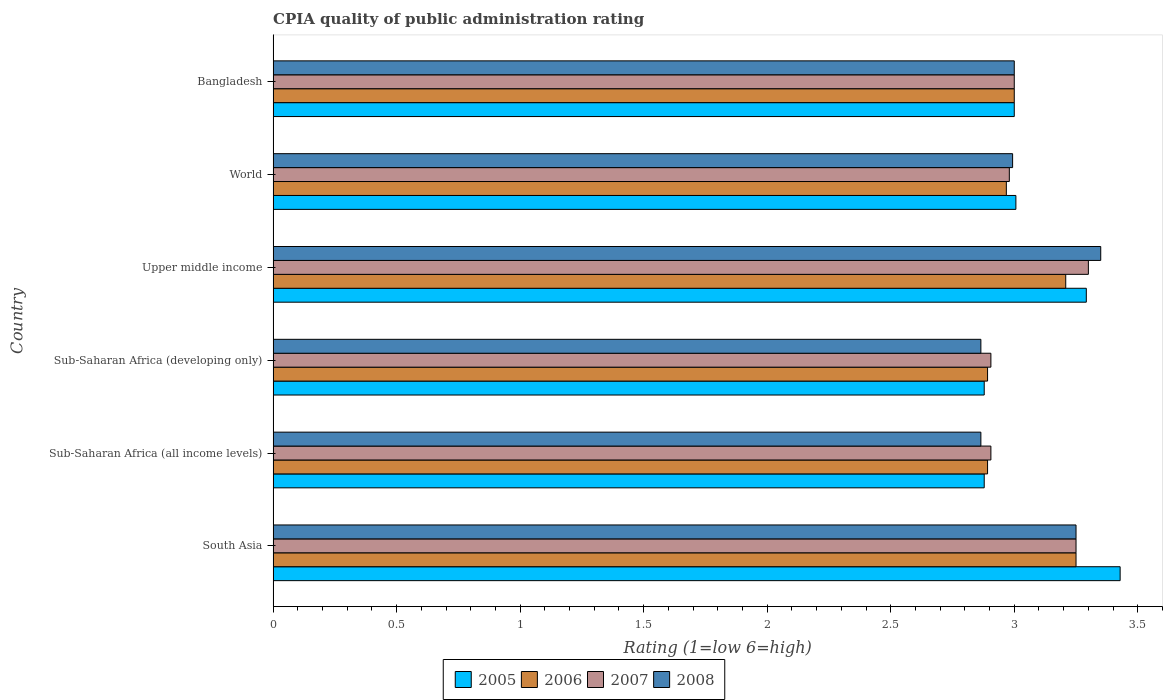How many different coloured bars are there?
Offer a terse response. 4. Are the number of bars per tick equal to the number of legend labels?
Your answer should be compact. Yes. Are the number of bars on each tick of the Y-axis equal?
Provide a succinct answer. Yes. How many bars are there on the 1st tick from the top?
Your answer should be compact. 4. What is the label of the 1st group of bars from the top?
Your answer should be compact. Bangladesh. What is the CPIA rating in 2005 in World?
Offer a terse response. 3.01. Across all countries, what is the minimum CPIA rating in 2006?
Your answer should be compact. 2.89. In which country was the CPIA rating in 2005 maximum?
Provide a short and direct response. South Asia. In which country was the CPIA rating in 2006 minimum?
Your response must be concise. Sub-Saharan Africa (all income levels). What is the total CPIA rating in 2006 in the graph?
Your response must be concise. 18.21. What is the difference between the CPIA rating in 2008 in Sub-Saharan Africa (all income levels) and that in Upper middle income?
Offer a very short reply. -0.49. What is the difference between the CPIA rating in 2006 in Sub-Saharan Africa (developing only) and the CPIA rating in 2008 in World?
Make the answer very short. -0.1. What is the average CPIA rating in 2005 per country?
Your answer should be compact. 3.08. What is the difference between the CPIA rating in 2005 and CPIA rating in 2007 in Upper middle income?
Your response must be concise. -0.01. In how many countries, is the CPIA rating in 2005 greater than 1.2 ?
Provide a succinct answer. 6. What is the ratio of the CPIA rating in 2007 in Sub-Saharan Africa (developing only) to that in Upper middle income?
Give a very brief answer. 0.88. Is the difference between the CPIA rating in 2005 in South Asia and World greater than the difference between the CPIA rating in 2007 in South Asia and World?
Provide a succinct answer. Yes. What is the difference between the highest and the second highest CPIA rating in 2005?
Ensure brevity in your answer.  0.14. What is the difference between the highest and the lowest CPIA rating in 2008?
Your answer should be very brief. 0.49. Is it the case that in every country, the sum of the CPIA rating in 2006 and CPIA rating in 2008 is greater than the sum of CPIA rating in 2005 and CPIA rating in 2007?
Your response must be concise. No. What does the 3rd bar from the top in South Asia represents?
Provide a short and direct response. 2006. Is it the case that in every country, the sum of the CPIA rating in 2008 and CPIA rating in 2005 is greater than the CPIA rating in 2007?
Give a very brief answer. Yes. How many bars are there?
Offer a very short reply. 24. Does the graph contain grids?
Provide a short and direct response. No. How are the legend labels stacked?
Your answer should be compact. Horizontal. What is the title of the graph?
Keep it short and to the point. CPIA quality of public administration rating. Does "1967" appear as one of the legend labels in the graph?
Give a very brief answer. No. What is the label or title of the X-axis?
Make the answer very short. Rating (1=low 6=high). What is the label or title of the Y-axis?
Offer a very short reply. Country. What is the Rating (1=low 6=high) of 2005 in South Asia?
Offer a very short reply. 3.43. What is the Rating (1=low 6=high) in 2006 in South Asia?
Your response must be concise. 3.25. What is the Rating (1=low 6=high) in 2008 in South Asia?
Your response must be concise. 3.25. What is the Rating (1=low 6=high) of 2005 in Sub-Saharan Africa (all income levels)?
Make the answer very short. 2.88. What is the Rating (1=low 6=high) of 2006 in Sub-Saharan Africa (all income levels)?
Ensure brevity in your answer.  2.89. What is the Rating (1=low 6=high) of 2007 in Sub-Saharan Africa (all income levels)?
Your response must be concise. 2.91. What is the Rating (1=low 6=high) in 2008 in Sub-Saharan Africa (all income levels)?
Give a very brief answer. 2.86. What is the Rating (1=low 6=high) of 2005 in Sub-Saharan Africa (developing only)?
Provide a succinct answer. 2.88. What is the Rating (1=low 6=high) in 2006 in Sub-Saharan Africa (developing only)?
Ensure brevity in your answer.  2.89. What is the Rating (1=low 6=high) in 2007 in Sub-Saharan Africa (developing only)?
Keep it short and to the point. 2.91. What is the Rating (1=low 6=high) of 2008 in Sub-Saharan Africa (developing only)?
Provide a succinct answer. 2.86. What is the Rating (1=low 6=high) of 2005 in Upper middle income?
Provide a succinct answer. 3.29. What is the Rating (1=low 6=high) of 2006 in Upper middle income?
Offer a very short reply. 3.21. What is the Rating (1=low 6=high) in 2007 in Upper middle income?
Your answer should be very brief. 3.3. What is the Rating (1=low 6=high) in 2008 in Upper middle income?
Your response must be concise. 3.35. What is the Rating (1=low 6=high) of 2005 in World?
Ensure brevity in your answer.  3.01. What is the Rating (1=low 6=high) of 2006 in World?
Offer a very short reply. 2.97. What is the Rating (1=low 6=high) in 2007 in World?
Provide a short and direct response. 2.98. What is the Rating (1=low 6=high) in 2008 in World?
Keep it short and to the point. 2.99. What is the Rating (1=low 6=high) in 2006 in Bangladesh?
Offer a terse response. 3. Across all countries, what is the maximum Rating (1=low 6=high) in 2005?
Provide a succinct answer. 3.43. Across all countries, what is the maximum Rating (1=low 6=high) of 2006?
Your response must be concise. 3.25. Across all countries, what is the maximum Rating (1=low 6=high) of 2008?
Provide a succinct answer. 3.35. Across all countries, what is the minimum Rating (1=low 6=high) of 2005?
Provide a short and direct response. 2.88. Across all countries, what is the minimum Rating (1=low 6=high) of 2006?
Keep it short and to the point. 2.89. Across all countries, what is the minimum Rating (1=low 6=high) of 2007?
Ensure brevity in your answer.  2.91. Across all countries, what is the minimum Rating (1=low 6=high) of 2008?
Make the answer very short. 2.86. What is the total Rating (1=low 6=high) of 2005 in the graph?
Offer a terse response. 18.48. What is the total Rating (1=low 6=high) in 2006 in the graph?
Your answer should be very brief. 18.21. What is the total Rating (1=low 6=high) in 2007 in the graph?
Provide a succinct answer. 18.34. What is the total Rating (1=low 6=high) of 2008 in the graph?
Make the answer very short. 18.32. What is the difference between the Rating (1=low 6=high) of 2005 in South Asia and that in Sub-Saharan Africa (all income levels)?
Keep it short and to the point. 0.55. What is the difference between the Rating (1=low 6=high) in 2006 in South Asia and that in Sub-Saharan Africa (all income levels)?
Provide a short and direct response. 0.36. What is the difference between the Rating (1=low 6=high) in 2007 in South Asia and that in Sub-Saharan Africa (all income levels)?
Your answer should be compact. 0.34. What is the difference between the Rating (1=low 6=high) of 2008 in South Asia and that in Sub-Saharan Africa (all income levels)?
Offer a terse response. 0.39. What is the difference between the Rating (1=low 6=high) in 2005 in South Asia and that in Sub-Saharan Africa (developing only)?
Your answer should be very brief. 0.55. What is the difference between the Rating (1=low 6=high) in 2006 in South Asia and that in Sub-Saharan Africa (developing only)?
Provide a succinct answer. 0.36. What is the difference between the Rating (1=low 6=high) of 2007 in South Asia and that in Sub-Saharan Africa (developing only)?
Make the answer very short. 0.34. What is the difference between the Rating (1=low 6=high) in 2008 in South Asia and that in Sub-Saharan Africa (developing only)?
Offer a terse response. 0.39. What is the difference between the Rating (1=low 6=high) in 2005 in South Asia and that in Upper middle income?
Give a very brief answer. 0.14. What is the difference between the Rating (1=low 6=high) in 2006 in South Asia and that in Upper middle income?
Make the answer very short. 0.04. What is the difference between the Rating (1=low 6=high) of 2007 in South Asia and that in Upper middle income?
Give a very brief answer. -0.05. What is the difference between the Rating (1=low 6=high) of 2008 in South Asia and that in Upper middle income?
Keep it short and to the point. -0.1. What is the difference between the Rating (1=low 6=high) in 2005 in South Asia and that in World?
Keep it short and to the point. 0.42. What is the difference between the Rating (1=low 6=high) of 2006 in South Asia and that in World?
Offer a very short reply. 0.28. What is the difference between the Rating (1=low 6=high) of 2007 in South Asia and that in World?
Provide a succinct answer. 0.27. What is the difference between the Rating (1=low 6=high) of 2008 in South Asia and that in World?
Provide a succinct answer. 0.26. What is the difference between the Rating (1=low 6=high) in 2005 in South Asia and that in Bangladesh?
Keep it short and to the point. 0.43. What is the difference between the Rating (1=low 6=high) in 2007 in South Asia and that in Bangladesh?
Keep it short and to the point. 0.25. What is the difference between the Rating (1=low 6=high) of 2005 in Sub-Saharan Africa (all income levels) and that in Sub-Saharan Africa (developing only)?
Provide a succinct answer. 0. What is the difference between the Rating (1=low 6=high) of 2007 in Sub-Saharan Africa (all income levels) and that in Sub-Saharan Africa (developing only)?
Make the answer very short. 0. What is the difference between the Rating (1=low 6=high) in 2008 in Sub-Saharan Africa (all income levels) and that in Sub-Saharan Africa (developing only)?
Give a very brief answer. 0. What is the difference between the Rating (1=low 6=high) in 2005 in Sub-Saharan Africa (all income levels) and that in Upper middle income?
Keep it short and to the point. -0.41. What is the difference between the Rating (1=low 6=high) in 2006 in Sub-Saharan Africa (all income levels) and that in Upper middle income?
Offer a very short reply. -0.32. What is the difference between the Rating (1=low 6=high) of 2007 in Sub-Saharan Africa (all income levels) and that in Upper middle income?
Your answer should be very brief. -0.39. What is the difference between the Rating (1=low 6=high) of 2008 in Sub-Saharan Africa (all income levels) and that in Upper middle income?
Make the answer very short. -0.49. What is the difference between the Rating (1=low 6=high) of 2005 in Sub-Saharan Africa (all income levels) and that in World?
Offer a terse response. -0.13. What is the difference between the Rating (1=low 6=high) in 2006 in Sub-Saharan Africa (all income levels) and that in World?
Your answer should be compact. -0.08. What is the difference between the Rating (1=low 6=high) of 2007 in Sub-Saharan Africa (all income levels) and that in World?
Offer a terse response. -0.07. What is the difference between the Rating (1=low 6=high) in 2008 in Sub-Saharan Africa (all income levels) and that in World?
Offer a very short reply. -0.13. What is the difference between the Rating (1=low 6=high) in 2005 in Sub-Saharan Africa (all income levels) and that in Bangladesh?
Your answer should be very brief. -0.12. What is the difference between the Rating (1=low 6=high) of 2006 in Sub-Saharan Africa (all income levels) and that in Bangladesh?
Offer a terse response. -0.11. What is the difference between the Rating (1=low 6=high) in 2007 in Sub-Saharan Africa (all income levels) and that in Bangladesh?
Keep it short and to the point. -0.09. What is the difference between the Rating (1=low 6=high) in 2008 in Sub-Saharan Africa (all income levels) and that in Bangladesh?
Offer a terse response. -0.14. What is the difference between the Rating (1=low 6=high) in 2005 in Sub-Saharan Africa (developing only) and that in Upper middle income?
Your answer should be compact. -0.41. What is the difference between the Rating (1=low 6=high) in 2006 in Sub-Saharan Africa (developing only) and that in Upper middle income?
Ensure brevity in your answer.  -0.32. What is the difference between the Rating (1=low 6=high) of 2007 in Sub-Saharan Africa (developing only) and that in Upper middle income?
Ensure brevity in your answer.  -0.39. What is the difference between the Rating (1=low 6=high) of 2008 in Sub-Saharan Africa (developing only) and that in Upper middle income?
Offer a very short reply. -0.49. What is the difference between the Rating (1=low 6=high) in 2005 in Sub-Saharan Africa (developing only) and that in World?
Keep it short and to the point. -0.13. What is the difference between the Rating (1=low 6=high) of 2006 in Sub-Saharan Africa (developing only) and that in World?
Your response must be concise. -0.08. What is the difference between the Rating (1=low 6=high) in 2007 in Sub-Saharan Africa (developing only) and that in World?
Your answer should be compact. -0.07. What is the difference between the Rating (1=low 6=high) of 2008 in Sub-Saharan Africa (developing only) and that in World?
Give a very brief answer. -0.13. What is the difference between the Rating (1=low 6=high) of 2005 in Sub-Saharan Africa (developing only) and that in Bangladesh?
Your response must be concise. -0.12. What is the difference between the Rating (1=low 6=high) in 2006 in Sub-Saharan Africa (developing only) and that in Bangladesh?
Provide a succinct answer. -0.11. What is the difference between the Rating (1=low 6=high) in 2007 in Sub-Saharan Africa (developing only) and that in Bangladesh?
Ensure brevity in your answer.  -0.09. What is the difference between the Rating (1=low 6=high) of 2008 in Sub-Saharan Africa (developing only) and that in Bangladesh?
Provide a succinct answer. -0.14. What is the difference between the Rating (1=low 6=high) in 2005 in Upper middle income and that in World?
Offer a terse response. 0.29. What is the difference between the Rating (1=low 6=high) in 2006 in Upper middle income and that in World?
Offer a very short reply. 0.24. What is the difference between the Rating (1=low 6=high) in 2007 in Upper middle income and that in World?
Ensure brevity in your answer.  0.32. What is the difference between the Rating (1=low 6=high) in 2008 in Upper middle income and that in World?
Ensure brevity in your answer.  0.36. What is the difference between the Rating (1=low 6=high) in 2005 in Upper middle income and that in Bangladesh?
Offer a very short reply. 0.29. What is the difference between the Rating (1=low 6=high) in 2006 in Upper middle income and that in Bangladesh?
Provide a succinct answer. 0.21. What is the difference between the Rating (1=low 6=high) in 2007 in Upper middle income and that in Bangladesh?
Offer a terse response. 0.3. What is the difference between the Rating (1=low 6=high) of 2005 in World and that in Bangladesh?
Offer a very short reply. 0.01. What is the difference between the Rating (1=low 6=high) of 2006 in World and that in Bangladesh?
Your response must be concise. -0.03. What is the difference between the Rating (1=low 6=high) of 2007 in World and that in Bangladesh?
Keep it short and to the point. -0.02. What is the difference between the Rating (1=low 6=high) of 2008 in World and that in Bangladesh?
Offer a very short reply. -0.01. What is the difference between the Rating (1=low 6=high) of 2005 in South Asia and the Rating (1=low 6=high) of 2006 in Sub-Saharan Africa (all income levels)?
Your response must be concise. 0.54. What is the difference between the Rating (1=low 6=high) of 2005 in South Asia and the Rating (1=low 6=high) of 2007 in Sub-Saharan Africa (all income levels)?
Offer a very short reply. 0.52. What is the difference between the Rating (1=low 6=high) of 2005 in South Asia and the Rating (1=low 6=high) of 2008 in Sub-Saharan Africa (all income levels)?
Give a very brief answer. 0.56. What is the difference between the Rating (1=low 6=high) in 2006 in South Asia and the Rating (1=low 6=high) in 2007 in Sub-Saharan Africa (all income levels)?
Provide a short and direct response. 0.34. What is the difference between the Rating (1=low 6=high) of 2006 in South Asia and the Rating (1=low 6=high) of 2008 in Sub-Saharan Africa (all income levels)?
Keep it short and to the point. 0.39. What is the difference between the Rating (1=low 6=high) of 2007 in South Asia and the Rating (1=low 6=high) of 2008 in Sub-Saharan Africa (all income levels)?
Your answer should be very brief. 0.39. What is the difference between the Rating (1=low 6=high) of 2005 in South Asia and the Rating (1=low 6=high) of 2006 in Sub-Saharan Africa (developing only)?
Provide a succinct answer. 0.54. What is the difference between the Rating (1=low 6=high) in 2005 in South Asia and the Rating (1=low 6=high) in 2007 in Sub-Saharan Africa (developing only)?
Your answer should be compact. 0.52. What is the difference between the Rating (1=low 6=high) in 2005 in South Asia and the Rating (1=low 6=high) in 2008 in Sub-Saharan Africa (developing only)?
Provide a short and direct response. 0.56. What is the difference between the Rating (1=low 6=high) in 2006 in South Asia and the Rating (1=low 6=high) in 2007 in Sub-Saharan Africa (developing only)?
Provide a succinct answer. 0.34. What is the difference between the Rating (1=low 6=high) in 2006 in South Asia and the Rating (1=low 6=high) in 2008 in Sub-Saharan Africa (developing only)?
Your response must be concise. 0.39. What is the difference between the Rating (1=low 6=high) in 2007 in South Asia and the Rating (1=low 6=high) in 2008 in Sub-Saharan Africa (developing only)?
Your response must be concise. 0.39. What is the difference between the Rating (1=low 6=high) of 2005 in South Asia and the Rating (1=low 6=high) of 2006 in Upper middle income?
Provide a short and direct response. 0.22. What is the difference between the Rating (1=low 6=high) in 2005 in South Asia and the Rating (1=low 6=high) in 2007 in Upper middle income?
Offer a terse response. 0.13. What is the difference between the Rating (1=low 6=high) in 2005 in South Asia and the Rating (1=low 6=high) in 2008 in Upper middle income?
Your answer should be very brief. 0.08. What is the difference between the Rating (1=low 6=high) in 2006 in South Asia and the Rating (1=low 6=high) in 2008 in Upper middle income?
Offer a terse response. -0.1. What is the difference between the Rating (1=low 6=high) of 2007 in South Asia and the Rating (1=low 6=high) of 2008 in Upper middle income?
Your response must be concise. -0.1. What is the difference between the Rating (1=low 6=high) in 2005 in South Asia and the Rating (1=low 6=high) in 2006 in World?
Give a very brief answer. 0.46. What is the difference between the Rating (1=low 6=high) of 2005 in South Asia and the Rating (1=low 6=high) of 2007 in World?
Give a very brief answer. 0.45. What is the difference between the Rating (1=low 6=high) of 2005 in South Asia and the Rating (1=low 6=high) of 2008 in World?
Your answer should be compact. 0.44. What is the difference between the Rating (1=low 6=high) of 2006 in South Asia and the Rating (1=low 6=high) of 2007 in World?
Your response must be concise. 0.27. What is the difference between the Rating (1=low 6=high) of 2006 in South Asia and the Rating (1=low 6=high) of 2008 in World?
Offer a very short reply. 0.26. What is the difference between the Rating (1=low 6=high) of 2007 in South Asia and the Rating (1=low 6=high) of 2008 in World?
Provide a succinct answer. 0.26. What is the difference between the Rating (1=low 6=high) in 2005 in South Asia and the Rating (1=low 6=high) in 2006 in Bangladesh?
Your response must be concise. 0.43. What is the difference between the Rating (1=low 6=high) of 2005 in South Asia and the Rating (1=low 6=high) of 2007 in Bangladesh?
Offer a very short reply. 0.43. What is the difference between the Rating (1=low 6=high) in 2005 in South Asia and the Rating (1=low 6=high) in 2008 in Bangladesh?
Offer a very short reply. 0.43. What is the difference between the Rating (1=low 6=high) in 2006 in South Asia and the Rating (1=low 6=high) in 2007 in Bangladesh?
Your answer should be very brief. 0.25. What is the difference between the Rating (1=low 6=high) of 2007 in South Asia and the Rating (1=low 6=high) of 2008 in Bangladesh?
Your answer should be compact. 0.25. What is the difference between the Rating (1=low 6=high) of 2005 in Sub-Saharan Africa (all income levels) and the Rating (1=low 6=high) of 2006 in Sub-Saharan Africa (developing only)?
Your response must be concise. -0.01. What is the difference between the Rating (1=low 6=high) in 2005 in Sub-Saharan Africa (all income levels) and the Rating (1=low 6=high) in 2007 in Sub-Saharan Africa (developing only)?
Keep it short and to the point. -0.03. What is the difference between the Rating (1=low 6=high) in 2005 in Sub-Saharan Africa (all income levels) and the Rating (1=low 6=high) in 2008 in Sub-Saharan Africa (developing only)?
Ensure brevity in your answer.  0.01. What is the difference between the Rating (1=low 6=high) of 2006 in Sub-Saharan Africa (all income levels) and the Rating (1=low 6=high) of 2007 in Sub-Saharan Africa (developing only)?
Offer a terse response. -0.01. What is the difference between the Rating (1=low 6=high) of 2006 in Sub-Saharan Africa (all income levels) and the Rating (1=low 6=high) of 2008 in Sub-Saharan Africa (developing only)?
Your answer should be compact. 0.03. What is the difference between the Rating (1=low 6=high) of 2007 in Sub-Saharan Africa (all income levels) and the Rating (1=low 6=high) of 2008 in Sub-Saharan Africa (developing only)?
Give a very brief answer. 0.04. What is the difference between the Rating (1=low 6=high) of 2005 in Sub-Saharan Africa (all income levels) and the Rating (1=low 6=high) of 2006 in Upper middle income?
Your answer should be very brief. -0.33. What is the difference between the Rating (1=low 6=high) in 2005 in Sub-Saharan Africa (all income levels) and the Rating (1=low 6=high) in 2007 in Upper middle income?
Provide a short and direct response. -0.42. What is the difference between the Rating (1=low 6=high) of 2005 in Sub-Saharan Africa (all income levels) and the Rating (1=low 6=high) of 2008 in Upper middle income?
Keep it short and to the point. -0.47. What is the difference between the Rating (1=low 6=high) in 2006 in Sub-Saharan Africa (all income levels) and the Rating (1=low 6=high) in 2007 in Upper middle income?
Ensure brevity in your answer.  -0.41. What is the difference between the Rating (1=low 6=high) of 2006 in Sub-Saharan Africa (all income levels) and the Rating (1=low 6=high) of 2008 in Upper middle income?
Ensure brevity in your answer.  -0.46. What is the difference between the Rating (1=low 6=high) in 2007 in Sub-Saharan Africa (all income levels) and the Rating (1=low 6=high) in 2008 in Upper middle income?
Ensure brevity in your answer.  -0.44. What is the difference between the Rating (1=low 6=high) of 2005 in Sub-Saharan Africa (all income levels) and the Rating (1=low 6=high) of 2006 in World?
Your answer should be very brief. -0.09. What is the difference between the Rating (1=low 6=high) in 2005 in Sub-Saharan Africa (all income levels) and the Rating (1=low 6=high) in 2007 in World?
Ensure brevity in your answer.  -0.1. What is the difference between the Rating (1=low 6=high) in 2005 in Sub-Saharan Africa (all income levels) and the Rating (1=low 6=high) in 2008 in World?
Provide a short and direct response. -0.12. What is the difference between the Rating (1=low 6=high) of 2006 in Sub-Saharan Africa (all income levels) and the Rating (1=low 6=high) of 2007 in World?
Ensure brevity in your answer.  -0.09. What is the difference between the Rating (1=low 6=high) in 2006 in Sub-Saharan Africa (all income levels) and the Rating (1=low 6=high) in 2008 in World?
Make the answer very short. -0.1. What is the difference between the Rating (1=low 6=high) of 2007 in Sub-Saharan Africa (all income levels) and the Rating (1=low 6=high) of 2008 in World?
Provide a succinct answer. -0.09. What is the difference between the Rating (1=low 6=high) of 2005 in Sub-Saharan Africa (all income levels) and the Rating (1=low 6=high) of 2006 in Bangladesh?
Your answer should be compact. -0.12. What is the difference between the Rating (1=low 6=high) of 2005 in Sub-Saharan Africa (all income levels) and the Rating (1=low 6=high) of 2007 in Bangladesh?
Offer a very short reply. -0.12. What is the difference between the Rating (1=low 6=high) of 2005 in Sub-Saharan Africa (all income levels) and the Rating (1=low 6=high) of 2008 in Bangladesh?
Provide a short and direct response. -0.12. What is the difference between the Rating (1=low 6=high) of 2006 in Sub-Saharan Africa (all income levels) and the Rating (1=low 6=high) of 2007 in Bangladesh?
Ensure brevity in your answer.  -0.11. What is the difference between the Rating (1=low 6=high) in 2006 in Sub-Saharan Africa (all income levels) and the Rating (1=low 6=high) in 2008 in Bangladesh?
Give a very brief answer. -0.11. What is the difference between the Rating (1=low 6=high) in 2007 in Sub-Saharan Africa (all income levels) and the Rating (1=low 6=high) in 2008 in Bangladesh?
Offer a terse response. -0.09. What is the difference between the Rating (1=low 6=high) of 2005 in Sub-Saharan Africa (developing only) and the Rating (1=low 6=high) of 2006 in Upper middle income?
Give a very brief answer. -0.33. What is the difference between the Rating (1=low 6=high) in 2005 in Sub-Saharan Africa (developing only) and the Rating (1=low 6=high) in 2007 in Upper middle income?
Make the answer very short. -0.42. What is the difference between the Rating (1=low 6=high) in 2005 in Sub-Saharan Africa (developing only) and the Rating (1=low 6=high) in 2008 in Upper middle income?
Provide a succinct answer. -0.47. What is the difference between the Rating (1=low 6=high) in 2006 in Sub-Saharan Africa (developing only) and the Rating (1=low 6=high) in 2007 in Upper middle income?
Offer a terse response. -0.41. What is the difference between the Rating (1=low 6=high) in 2006 in Sub-Saharan Africa (developing only) and the Rating (1=low 6=high) in 2008 in Upper middle income?
Provide a succinct answer. -0.46. What is the difference between the Rating (1=low 6=high) of 2007 in Sub-Saharan Africa (developing only) and the Rating (1=low 6=high) of 2008 in Upper middle income?
Keep it short and to the point. -0.44. What is the difference between the Rating (1=low 6=high) of 2005 in Sub-Saharan Africa (developing only) and the Rating (1=low 6=high) of 2006 in World?
Your response must be concise. -0.09. What is the difference between the Rating (1=low 6=high) in 2005 in Sub-Saharan Africa (developing only) and the Rating (1=low 6=high) in 2007 in World?
Give a very brief answer. -0.1. What is the difference between the Rating (1=low 6=high) in 2005 in Sub-Saharan Africa (developing only) and the Rating (1=low 6=high) in 2008 in World?
Your answer should be compact. -0.12. What is the difference between the Rating (1=low 6=high) in 2006 in Sub-Saharan Africa (developing only) and the Rating (1=low 6=high) in 2007 in World?
Provide a succinct answer. -0.09. What is the difference between the Rating (1=low 6=high) in 2006 in Sub-Saharan Africa (developing only) and the Rating (1=low 6=high) in 2008 in World?
Provide a short and direct response. -0.1. What is the difference between the Rating (1=low 6=high) of 2007 in Sub-Saharan Africa (developing only) and the Rating (1=low 6=high) of 2008 in World?
Offer a terse response. -0.09. What is the difference between the Rating (1=low 6=high) in 2005 in Sub-Saharan Africa (developing only) and the Rating (1=low 6=high) in 2006 in Bangladesh?
Offer a terse response. -0.12. What is the difference between the Rating (1=low 6=high) of 2005 in Sub-Saharan Africa (developing only) and the Rating (1=low 6=high) of 2007 in Bangladesh?
Your answer should be compact. -0.12. What is the difference between the Rating (1=low 6=high) in 2005 in Sub-Saharan Africa (developing only) and the Rating (1=low 6=high) in 2008 in Bangladesh?
Make the answer very short. -0.12. What is the difference between the Rating (1=low 6=high) of 2006 in Sub-Saharan Africa (developing only) and the Rating (1=low 6=high) of 2007 in Bangladesh?
Make the answer very short. -0.11. What is the difference between the Rating (1=low 6=high) of 2006 in Sub-Saharan Africa (developing only) and the Rating (1=low 6=high) of 2008 in Bangladesh?
Keep it short and to the point. -0.11. What is the difference between the Rating (1=low 6=high) of 2007 in Sub-Saharan Africa (developing only) and the Rating (1=low 6=high) of 2008 in Bangladesh?
Offer a terse response. -0.09. What is the difference between the Rating (1=low 6=high) of 2005 in Upper middle income and the Rating (1=low 6=high) of 2006 in World?
Offer a very short reply. 0.32. What is the difference between the Rating (1=low 6=high) in 2005 in Upper middle income and the Rating (1=low 6=high) in 2007 in World?
Give a very brief answer. 0.31. What is the difference between the Rating (1=low 6=high) of 2005 in Upper middle income and the Rating (1=low 6=high) of 2008 in World?
Keep it short and to the point. 0.3. What is the difference between the Rating (1=low 6=high) of 2006 in Upper middle income and the Rating (1=low 6=high) of 2007 in World?
Keep it short and to the point. 0.23. What is the difference between the Rating (1=low 6=high) in 2006 in Upper middle income and the Rating (1=low 6=high) in 2008 in World?
Give a very brief answer. 0.21. What is the difference between the Rating (1=low 6=high) of 2007 in Upper middle income and the Rating (1=low 6=high) of 2008 in World?
Offer a terse response. 0.31. What is the difference between the Rating (1=low 6=high) of 2005 in Upper middle income and the Rating (1=low 6=high) of 2006 in Bangladesh?
Keep it short and to the point. 0.29. What is the difference between the Rating (1=low 6=high) of 2005 in Upper middle income and the Rating (1=low 6=high) of 2007 in Bangladesh?
Your response must be concise. 0.29. What is the difference between the Rating (1=low 6=high) in 2005 in Upper middle income and the Rating (1=low 6=high) in 2008 in Bangladesh?
Your response must be concise. 0.29. What is the difference between the Rating (1=low 6=high) of 2006 in Upper middle income and the Rating (1=low 6=high) of 2007 in Bangladesh?
Offer a terse response. 0.21. What is the difference between the Rating (1=low 6=high) of 2006 in Upper middle income and the Rating (1=low 6=high) of 2008 in Bangladesh?
Offer a terse response. 0.21. What is the difference between the Rating (1=low 6=high) in 2007 in Upper middle income and the Rating (1=low 6=high) in 2008 in Bangladesh?
Keep it short and to the point. 0.3. What is the difference between the Rating (1=low 6=high) of 2005 in World and the Rating (1=low 6=high) of 2006 in Bangladesh?
Offer a very short reply. 0.01. What is the difference between the Rating (1=low 6=high) in 2005 in World and the Rating (1=low 6=high) in 2007 in Bangladesh?
Provide a short and direct response. 0.01. What is the difference between the Rating (1=low 6=high) in 2005 in World and the Rating (1=low 6=high) in 2008 in Bangladesh?
Offer a very short reply. 0.01. What is the difference between the Rating (1=low 6=high) in 2006 in World and the Rating (1=low 6=high) in 2007 in Bangladesh?
Keep it short and to the point. -0.03. What is the difference between the Rating (1=low 6=high) in 2006 in World and the Rating (1=low 6=high) in 2008 in Bangladesh?
Provide a short and direct response. -0.03. What is the difference between the Rating (1=low 6=high) of 2007 in World and the Rating (1=low 6=high) of 2008 in Bangladesh?
Your answer should be very brief. -0.02. What is the average Rating (1=low 6=high) in 2005 per country?
Your answer should be compact. 3.08. What is the average Rating (1=low 6=high) of 2006 per country?
Ensure brevity in your answer.  3.04. What is the average Rating (1=low 6=high) in 2007 per country?
Give a very brief answer. 3.06. What is the average Rating (1=low 6=high) of 2008 per country?
Make the answer very short. 3.05. What is the difference between the Rating (1=low 6=high) of 2005 and Rating (1=low 6=high) of 2006 in South Asia?
Provide a succinct answer. 0.18. What is the difference between the Rating (1=low 6=high) in 2005 and Rating (1=low 6=high) in 2007 in South Asia?
Provide a short and direct response. 0.18. What is the difference between the Rating (1=low 6=high) in 2005 and Rating (1=low 6=high) in 2008 in South Asia?
Make the answer very short. 0.18. What is the difference between the Rating (1=low 6=high) in 2006 and Rating (1=low 6=high) in 2008 in South Asia?
Give a very brief answer. 0. What is the difference between the Rating (1=low 6=high) of 2007 and Rating (1=low 6=high) of 2008 in South Asia?
Offer a terse response. 0. What is the difference between the Rating (1=low 6=high) of 2005 and Rating (1=low 6=high) of 2006 in Sub-Saharan Africa (all income levels)?
Make the answer very short. -0.01. What is the difference between the Rating (1=low 6=high) in 2005 and Rating (1=low 6=high) in 2007 in Sub-Saharan Africa (all income levels)?
Provide a succinct answer. -0.03. What is the difference between the Rating (1=low 6=high) of 2005 and Rating (1=low 6=high) of 2008 in Sub-Saharan Africa (all income levels)?
Make the answer very short. 0.01. What is the difference between the Rating (1=low 6=high) in 2006 and Rating (1=low 6=high) in 2007 in Sub-Saharan Africa (all income levels)?
Make the answer very short. -0.01. What is the difference between the Rating (1=low 6=high) in 2006 and Rating (1=low 6=high) in 2008 in Sub-Saharan Africa (all income levels)?
Your answer should be very brief. 0.03. What is the difference between the Rating (1=low 6=high) of 2007 and Rating (1=low 6=high) of 2008 in Sub-Saharan Africa (all income levels)?
Ensure brevity in your answer.  0.04. What is the difference between the Rating (1=low 6=high) of 2005 and Rating (1=low 6=high) of 2006 in Sub-Saharan Africa (developing only)?
Offer a very short reply. -0.01. What is the difference between the Rating (1=low 6=high) of 2005 and Rating (1=low 6=high) of 2007 in Sub-Saharan Africa (developing only)?
Your answer should be compact. -0.03. What is the difference between the Rating (1=low 6=high) in 2005 and Rating (1=low 6=high) in 2008 in Sub-Saharan Africa (developing only)?
Offer a very short reply. 0.01. What is the difference between the Rating (1=low 6=high) in 2006 and Rating (1=low 6=high) in 2007 in Sub-Saharan Africa (developing only)?
Ensure brevity in your answer.  -0.01. What is the difference between the Rating (1=low 6=high) of 2006 and Rating (1=low 6=high) of 2008 in Sub-Saharan Africa (developing only)?
Keep it short and to the point. 0.03. What is the difference between the Rating (1=low 6=high) of 2007 and Rating (1=low 6=high) of 2008 in Sub-Saharan Africa (developing only)?
Make the answer very short. 0.04. What is the difference between the Rating (1=low 6=high) in 2005 and Rating (1=low 6=high) in 2006 in Upper middle income?
Keep it short and to the point. 0.08. What is the difference between the Rating (1=low 6=high) of 2005 and Rating (1=low 6=high) of 2007 in Upper middle income?
Your answer should be compact. -0.01. What is the difference between the Rating (1=low 6=high) in 2005 and Rating (1=low 6=high) in 2008 in Upper middle income?
Make the answer very short. -0.06. What is the difference between the Rating (1=low 6=high) in 2006 and Rating (1=low 6=high) in 2007 in Upper middle income?
Provide a short and direct response. -0.09. What is the difference between the Rating (1=low 6=high) of 2006 and Rating (1=low 6=high) of 2008 in Upper middle income?
Your response must be concise. -0.14. What is the difference between the Rating (1=low 6=high) in 2007 and Rating (1=low 6=high) in 2008 in Upper middle income?
Your answer should be compact. -0.05. What is the difference between the Rating (1=low 6=high) of 2005 and Rating (1=low 6=high) of 2006 in World?
Your answer should be compact. 0.04. What is the difference between the Rating (1=low 6=high) in 2005 and Rating (1=low 6=high) in 2007 in World?
Offer a terse response. 0.03. What is the difference between the Rating (1=low 6=high) of 2005 and Rating (1=low 6=high) of 2008 in World?
Offer a very short reply. 0.01. What is the difference between the Rating (1=low 6=high) in 2006 and Rating (1=low 6=high) in 2007 in World?
Offer a very short reply. -0.01. What is the difference between the Rating (1=low 6=high) in 2006 and Rating (1=low 6=high) in 2008 in World?
Ensure brevity in your answer.  -0.03. What is the difference between the Rating (1=low 6=high) in 2007 and Rating (1=low 6=high) in 2008 in World?
Your response must be concise. -0.01. What is the difference between the Rating (1=low 6=high) in 2005 and Rating (1=low 6=high) in 2007 in Bangladesh?
Keep it short and to the point. 0. What is the difference between the Rating (1=low 6=high) of 2006 and Rating (1=low 6=high) of 2008 in Bangladesh?
Offer a very short reply. 0. What is the ratio of the Rating (1=low 6=high) in 2005 in South Asia to that in Sub-Saharan Africa (all income levels)?
Make the answer very short. 1.19. What is the ratio of the Rating (1=low 6=high) in 2006 in South Asia to that in Sub-Saharan Africa (all income levels)?
Offer a terse response. 1.12. What is the ratio of the Rating (1=low 6=high) of 2007 in South Asia to that in Sub-Saharan Africa (all income levels)?
Provide a succinct answer. 1.12. What is the ratio of the Rating (1=low 6=high) in 2008 in South Asia to that in Sub-Saharan Africa (all income levels)?
Give a very brief answer. 1.13. What is the ratio of the Rating (1=low 6=high) in 2005 in South Asia to that in Sub-Saharan Africa (developing only)?
Ensure brevity in your answer.  1.19. What is the ratio of the Rating (1=low 6=high) in 2006 in South Asia to that in Sub-Saharan Africa (developing only)?
Your answer should be compact. 1.12. What is the ratio of the Rating (1=low 6=high) in 2007 in South Asia to that in Sub-Saharan Africa (developing only)?
Provide a short and direct response. 1.12. What is the ratio of the Rating (1=low 6=high) of 2008 in South Asia to that in Sub-Saharan Africa (developing only)?
Make the answer very short. 1.13. What is the ratio of the Rating (1=low 6=high) in 2005 in South Asia to that in Upper middle income?
Your answer should be compact. 1.04. What is the ratio of the Rating (1=low 6=high) in 2007 in South Asia to that in Upper middle income?
Your answer should be compact. 0.98. What is the ratio of the Rating (1=low 6=high) of 2008 in South Asia to that in Upper middle income?
Provide a short and direct response. 0.97. What is the ratio of the Rating (1=low 6=high) of 2005 in South Asia to that in World?
Your response must be concise. 1.14. What is the ratio of the Rating (1=low 6=high) in 2006 in South Asia to that in World?
Keep it short and to the point. 1.09. What is the ratio of the Rating (1=low 6=high) of 2007 in South Asia to that in World?
Ensure brevity in your answer.  1.09. What is the ratio of the Rating (1=low 6=high) of 2008 in South Asia to that in World?
Offer a terse response. 1.09. What is the ratio of the Rating (1=low 6=high) in 2005 in South Asia to that in Bangladesh?
Keep it short and to the point. 1.14. What is the ratio of the Rating (1=low 6=high) of 2007 in South Asia to that in Bangladesh?
Make the answer very short. 1.08. What is the ratio of the Rating (1=low 6=high) of 2005 in Sub-Saharan Africa (all income levels) to that in Sub-Saharan Africa (developing only)?
Your answer should be very brief. 1. What is the ratio of the Rating (1=low 6=high) in 2006 in Sub-Saharan Africa (all income levels) to that in Sub-Saharan Africa (developing only)?
Your answer should be very brief. 1. What is the ratio of the Rating (1=low 6=high) of 2005 in Sub-Saharan Africa (all income levels) to that in Upper middle income?
Keep it short and to the point. 0.87. What is the ratio of the Rating (1=low 6=high) of 2006 in Sub-Saharan Africa (all income levels) to that in Upper middle income?
Your answer should be compact. 0.9. What is the ratio of the Rating (1=low 6=high) in 2007 in Sub-Saharan Africa (all income levels) to that in Upper middle income?
Your answer should be compact. 0.88. What is the ratio of the Rating (1=low 6=high) in 2008 in Sub-Saharan Africa (all income levels) to that in Upper middle income?
Provide a short and direct response. 0.86. What is the ratio of the Rating (1=low 6=high) of 2005 in Sub-Saharan Africa (all income levels) to that in World?
Your answer should be compact. 0.96. What is the ratio of the Rating (1=low 6=high) of 2006 in Sub-Saharan Africa (all income levels) to that in World?
Keep it short and to the point. 0.97. What is the ratio of the Rating (1=low 6=high) of 2008 in Sub-Saharan Africa (all income levels) to that in World?
Keep it short and to the point. 0.96. What is the ratio of the Rating (1=low 6=high) of 2005 in Sub-Saharan Africa (all income levels) to that in Bangladesh?
Provide a short and direct response. 0.96. What is the ratio of the Rating (1=low 6=high) of 2007 in Sub-Saharan Africa (all income levels) to that in Bangladesh?
Ensure brevity in your answer.  0.97. What is the ratio of the Rating (1=low 6=high) in 2008 in Sub-Saharan Africa (all income levels) to that in Bangladesh?
Your answer should be very brief. 0.95. What is the ratio of the Rating (1=low 6=high) of 2005 in Sub-Saharan Africa (developing only) to that in Upper middle income?
Offer a terse response. 0.87. What is the ratio of the Rating (1=low 6=high) in 2006 in Sub-Saharan Africa (developing only) to that in Upper middle income?
Offer a very short reply. 0.9. What is the ratio of the Rating (1=low 6=high) of 2007 in Sub-Saharan Africa (developing only) to that in Upper middle income?
Ensure brevity in your answer.  0.88. What is the ratio of the Rating (1=low 6=high) in 2008 in Sub-Saharan Africa (developing only) to that in Upper middle income?
Make the answer very short. 0.86. What is the ratio of the Rating (1=low 6=high) in 2005 in Sub-Saharan Africa (developing only) to that in World?
Offer a very short reply. 0.96. What is the ratio of the Rating (1=low 6=high) in 2006 in Sub-Saharan Africa (developing only) to that in World?
Provide a short and direct response. 0.97. What is the ratio of the Rating (1=low 6=high) of 2008 in Sub-Saharan Africa (developing only) to that in World?
Your response must be concise. 0.96. What is the ratio of the Rating (1=low 6=high) of 2005 in Sub-Saharan Africa (developing only) to that in Bangladesh?
Make the answer very short. 0.96. What is the ratio of the Rating (1=low 6=high) of 2006 in Sub-Saharan Africa (developing only) to that in Bangladesh?
Give a very brief answer. 0.96. What is the ratio of the Rating (1=low 6=high) in 2007 in Sub-Saharan Africa (developing only) to that in Bangladesh?
Provide a short and direct response. 0.97. What is the ratio of the Rating (1=low 6=high) in 2008 in Sub-Saharan Africa (developing only) to that in Bangladesh?
Offer a very short reply. 0.95. What is the ratio of the Rating (1=low 6=high) in 2005 in Upper middle income to that in World?
Your response must be concise. 1.09. What is the ratio of the Rating (1=low 6=high) of 2006 in Upper middle income to that in World?
Provide a short and direct response. 1.08. What is the ratio of the Rating (1=low 6=high) in 2007 in Upper middle income to that in World?
Give a very brief answer. 1.11. What is the ratio of the Rating (1=low 6=high) in 2008 in Upper middle income to that in World?
Offer a terse response. 1.12. What is the ratio of the Rating (1=low 6=high) in 2005 in Upper middle income to that in Bangladesh?
Your response must be concise. 1.1. What is the ratio of the Rating (1=low 6=high) in 2006 in Upper middle income to that in Bangladesh?
Provide a succinct answer. 1.07. What is the ratio of the Rating (1=low 6=high) of 2007 in Upper middle income to that in Bangladesh?
Offer a terse response. 1.1. What is the ratio of the Rating (1=low 6=high) in 2008 in Upper middle income to that in Bangladesh?
Offer a terse response. 1.12. What is the ratio of the Rating (1=low 6=high) in 2006 in World to that in Bangladesh?
Provide a short and direct response. 0.99. What is the ratio of the Rating (1=low 6=high) of 2007 in World to that in Bangladesh?
Ensure brevity in your answer.  0.99. What is the difference between the highest and the second highest Rating (1=low 6=high) of 2005?
Offer a terse response. 0.14. What is the difference between the highest and the second highest Rating (1=low 6=high) in 2006?
Offer a very short reply. 0.04. What is the difference between the highest and the lowest Rating (1=low 6=high) of 2005?
Keep it short and to the point. 0.55. What is the difference between the highest and the lowest Rating (1=low 6=high) in 2006?
Your answer should be very brief. 0.36. What is the difference between the highest and the lowest Rating (1=low 6=high) in 2007?
Provide a short and direct response. 0.39. What is the difference between the highest and the lowest Rating (1=low 6=high) of 2008?
Keep it short and to the point. 0.49. 